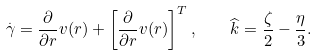<formula> <loc_0><loc_0><loc_500><loc_500>\overset { . } { \gamma } = \frac { \partial } { \partial r } v ( r ) + \left [ \frac { \partial } { \partial r } v ( r ) \right ] ^ { T } , \quad \widehat { k } = \frac { \zeta } { 2 } - \frac { \eta } { 3 } .</formula> 